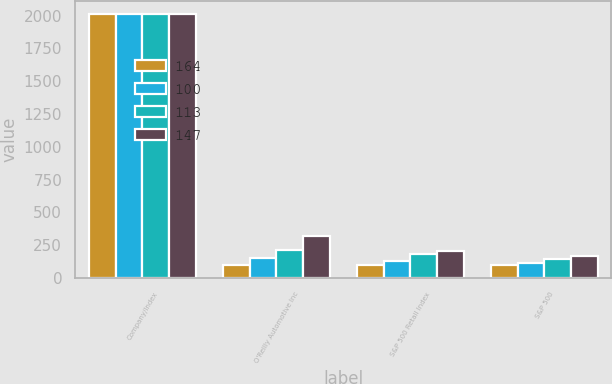Convert chart. <chart><loc_0><loc_0><loc_500><loc_500><stacked_bar_chart><ecel><fcel>Company/Index<fcel>O'Reilly Automotive Inc<fcel>S&P 500 Retail Index<fcel>S&P 500<nl><fcel>164<fcel>2010<fcel>100<fcel>100<fcel>100<nl><fcel>100<fcel>2012<fcel>148<fcel>128<fcel>113<nl><fcel>113<fcel>2013<fcel>213<fcel>185<fcel>147<nl><fcel>147<fcel>2014<fcel>319<fcel>203<fcel>164<nl></chart> 